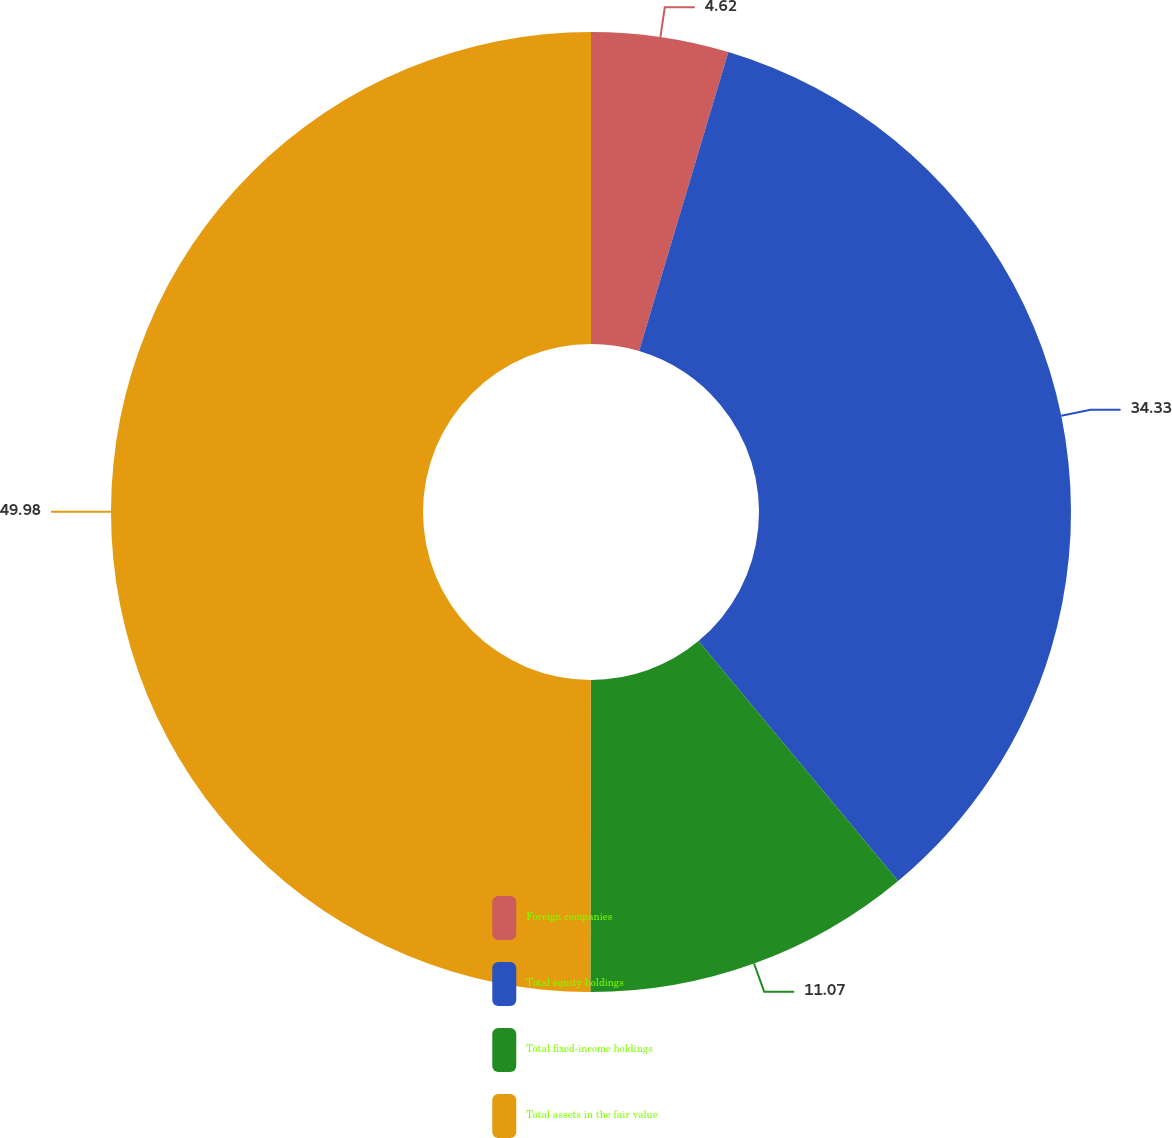Convert chart to OTSL. <chart><loc_0><loc_0><loc_500><loc_500><pie_chart><fcel>Foreign companies<fcel>Total equity holdings<fcel>Total fixed-income holdings<fcel>Total assets in the fair value<nl><fcel>4.62%<fcel>34.33%<fcel>11.07%<fcel>49.98%<nl></chart> 